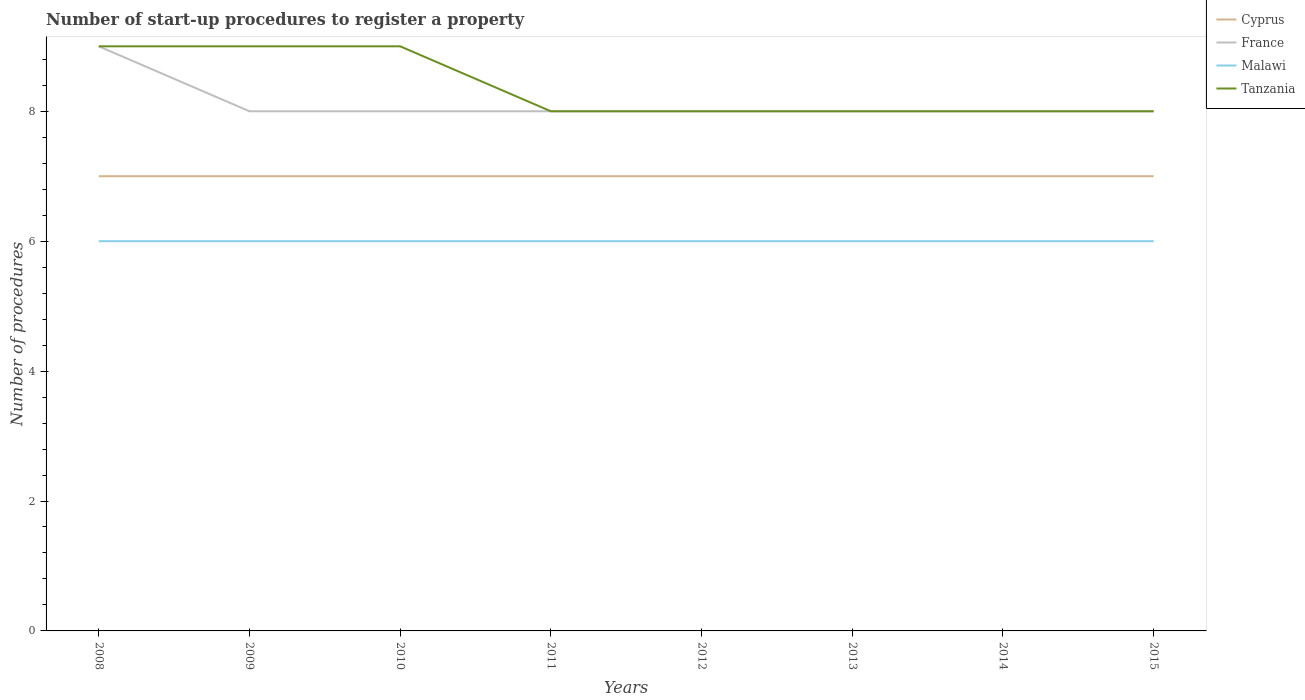Does the line corresponding to Malawi intersect with the line corresponding to Tanzania?
Give a very brief answer. No. Across all years, what is the maximum number of procedures required to register a property in Cyprus?
Keep it short and to the point. 7. In which year was the number of procedures required to register a property in Malawi maximum?
Your answer should be compact. 2008. What is the total number of procedures required to register a property in France in the graph?
Keep it short and to the point. 0. What is the difference between the highest and the second highest number of procedures required to register a property in Malawi?
Your answer should be compact. 0. What is the difference between the highest and the lowest number of procedures required to register a property in France?
Give a very brief answer. 1. Is the number of procedures required to register a property in Tanzania strictly greater than the number of procedures required to register a property in Cyprus over the years?
Provide a short and direct response. No. Where does the legend appear in the graph?
Provide a succinct answer. Top right. How many legend labels are there?
Ensure brevity in your answer.  4. How are the legend labels stacked?
Keep it short and to the point. Vertical. What is the title of the graph?
Make the answer very short. Number of start-up procedures to register a property. What is the label or title of the Y-axis?
Ensure brevity in your answer.  Number of procedures. What is the Number of procedures of France in 2008?
Make the answer very short. 9. What is the Number of procedures in Malawi in 2008?
Provide a succinct answer. 6. What is the Number of procedures in Tanzania in 2008?
Give a very brief answer. 9. What is the Number of procedures in Tanzania in 2009?
Your answer should be very brief. 9. What is the Number of procedures of Cyprus in 2010?
Offer a terse response. 7. What is the Number of procedures of France in 2010?
Make the answer very short. 8. What is the Number of procedures of Malawi in 2010?
Offer a very short reply. 6. What is the Number of procedures in Cyprus in 2011?
Give a very brief answer. 7. What is the Number of procedures in France in 2011?
Keep it short and to the point. 8. What is the Number of procedures in Malawi in 2011?
Offer a terse response. 6. What is the Number of procedures of Tanzania in 2011?
Provide a succinct answer. 8. What is the Number of procedures of Cyprus in 2012?
Offer a terse response. 7. What is the Number of procedures in France in 2012?
Ensure brevity in your answer.  8. What is the Number of procedures of Malawi in 2012?
Provide a succinct answer. 6. What is the Number of procedures in France in 2013?
Your answer should be very brief. 8. What is the Number of procedures of Cyprus in 2014?
Make the answer very short. 7. What is the Number of procedures of Malawi in 2014?
Your answer should be compact. 6. Across all years, what is the maximum Number of procedures in Cyprus?
Your response must be concise. 7. Across all years, what is the maximum Number of procedures in Tanzania?
Make the answer very short. 9. Across all years, what is the minimum Number of procedures of Cyprus?
Offer a very short reply. 7. Across all years, what is the minimum Number of procedures of Tanzania?
Your answer should be very brief. 8. What is the total Number of procedures of France in the graph?
Ensure brevity in your answer.  65. What is the total Number of procedures in Tanzania in the graph?
Your answer should be very brief. 67. What is the difference between the Number of procedures of Cyprus in 2008 and that in 2009?
Offer a terse response. 0. What is the difference between the Number of procedures in France in 2008 and that in 2009?
Your answer should be very brief. 1. What is the difference between the Number of procedures in Tanzania in 2008 and that in 2009?
Your answer should be very brief. 0. What is the difference between the Number of procedures in France in 2008 and that in 2010?
Offer a terse response. 1. What is the difference between the Number of procedures in Tanzania in 2008 and that in 2010?
Offer a very short reply. 0. What is the difference between the Number of procedures in Cyprus in 2008 and that in 2011?
Give a very brief answer. 0. What is the difference between the Number of procedures of France in 2008 and that in 2011?
Provide a short and direct response. 1. What is the difference between the Number of procedures of France in 2008 and that in 2012?
Your answer should be very brief. 1. What is the difference between the Number of procedures in France in 2008 and that in 2013?
Give a very brief answer. 1. What is the difference between the Number of procedures of Malawi in 2008 and that in 2013?
Make the answer very short. 0. What is the difference between the Number of procedures in Tanzania in 2008 and that in 2013?
Keep it short and to the point. 1. What is the difference between the Number of procedures of Tanzania in 2008 and that in 2014?
Keep it short and to the point. 1. What is the difference between the Number of procedures of France in 2009 and that in 2010?
Your answer should be very brief. 0. What is the difference between the Number of procedures of Malawi in 2009 and that in 2010?
Make the answer very short. 0. What is the difference between the Number of procedures of Cyprus in 2009 and that in 2011?
Provide a succinct answer. 0. What is the difference between the Number of procedures of France in 2009 and that in 2011?
Offer a very short reply. 0. What is the difference between the Number of procedures of Malawi in 2009 and that in 2011?
Provide a succinct answer. 0. What is the difference between the Number of procedures in Tanzania in 2009 and that in 2011?
Ensure brevity in your answer.  1. What is the difference between the Number of procedures of Malawi in 2009 and that in 2012?
Provide a short and direct response. 0. What is the difference between the Number of procedures in Tanzania in 2009 and that in 2012?
Provide a short and direct response. 1. What is the difference between the Number of procedures in France in 2009 and that in 2013?
Your answer should be compact. 0. What is the difference between the Number of procedures of Malawi in 2009 and that in 2013?
Give a very brief answer. 0. What is the difference between the Number of procedures in Tanzania in 2009 and that in 2013?
Your response must be concise. 1. What is the difference between the Number of procedures of Cyprus in 2009 and that in 2014?
Your answer should be very brief. 0. What is the difference between the Number of procedures in France in 2009 and that in 2014?
Offer a terse response. 0. What is the difference between the Number of procedures in Cyprus in 2010 and that in 2011?
Make the answer very short. 0. What is the difference between the Number of procedures in France in 2010 and that in 2011?
Your response must be concise. 0. What is the difference between the Number of procedures in Malawi in 2010 and that in 2011?
Your answer should be compact. 0. What is the difference between the Number of procedures of Tanzania in 2010 and that in 2011?
Give a very brief answer. 1. What is the difference between the Number of procedures in Cyprus in 2010 and that in 2012?
Ensure brevity in your answer.  0. What is the difference between the Number of procedures of France in 2010 and that in 2012?
Offer a terse response. 0. What is the difference between the Number of procedures in Tanzania in 2010 and that in 2012?
Your answer should be compact. 1. What is the difference between the Number of procedures of Cyprus in 2010 and that in 2013?
Give a very brief answer. 0. What is the difference between the Number of procedures of France in 2010 and that in 2013?
Ensure brevity in your answer.  0. What is the difference between the Number of procedures in Malawi in 2010 and that in 2013?
Offer a terse response. 0. What is the difference between the Number of procedures in Tanzania in 2010 and that in 2013?
Your answer should be compact. 1. What is the difference between the Number of procedures in Cyprus in 2010 and that in 2014?
Your answer should be very brief. 0. What is the difference between the Number of procedures of France in 2010 and that in 2014?
Offer a very short reply. 0. What is the difference between the Number of procedures in France in 2010 and that in 2015?
Make the answer very short. 0. What is the difference between the Number of procedures in Cyprus in 2011 and that in 2012?
Your answer should be compact. 0. What is the difference between the Number of procedures of Tanzania in 2011 and that in 2012?
Make the answer very short. 0. What is the difference between the Number of procedures of Cyprus in 2011 and that in 2013?
Keep it short and to the point. 0. What is the difference between the Number of procedures of Tanzania in 2011 and that in 2013?
Offer a very short reply. 0. What is the difference between the Number of procedures in Cyprus in 2011 and that in 2014?
Provide a short and direct response. 0. What is the difference between the Number of procedures in Tanzania in 2011 and that in 2014?
Offer a very short reply. 0. What is the difference between the Number of procedures in Cyprus in 2011 and that in 2015?
Offer a very short reply. 0. What is the difference between the Number of procedures of Malawi in 2011 and that in 2015?
Your response must be concise. 0. What is the difference between the Number of procedures in Cyprus in 2012 and that in 2013?
Make the answer very short. 0. What is the difference between the Number of procedures in Malawi in 2012 and that in 2013?
Your answer should be very brief. 0. What is the difference between the Number of procedures of Cyprus in 2012 and that in 2014?
Your response must be concise. 0. What is the difference between the Number of procedures in France in 2012 and that in 2014?
Offer a terse response. 0. What is the difference between the Number of procedures of Cyprus in 2012 and that in 2015?
Ensure brevity in your answer.  0. What is the difference between the Number of procedures of Malawi in 2012 and that in 2015?
Offer a terse response. 0. What is the difference between the Number of procedures in Tanzania in 2012 and that in 2015?
Your answer should be compact. 0. What is the difference between the Number of procedures of Cyprus in 2013 and that in 2014?
Give a very brief answer. 0. What is the difference between the Number of procedures in France in 2013 and that in 2014?
Ensure brevity in your answer.  0. What is the difference between the Number of procedures in Malawi in 2013 and that in 2014?
Your answer should be compact. 0. What is the difference between the Number of procedures in Tanzania in 2013 and that in 2014?
Provide a short and direct response. 0. What is the difference between the Number of procedures of Cyprus in 2013 and that in 2015?
Provide a short and direct response. 0. What is the difference between the Number of procedures of Malawi in 2013 and that in 2015?
Provide a short and direct response. 0. What is the difference between the Number of procedures in France in 2014 and that in 2015?
Your answer should be very brief. 0. What is the difference between the Number of procedures in Cyprus in 2008 and the Number of procedures in France in 2009?
Ensure brevity in your answer.  -1. What is the difference between the Number of procedures of Cyprus in 2008 and the Number of procedures of Tanzania in 2009?
Your answer should be compact. -2. What is the difference between the Number of procedures of Malawi in 2008 and the Number of procedures of Tanzania in 2009?
Give a very brief answer. -3. What is the difference between the Number of procedures in Cyprus in 2008 and the Number of procedures in Malawi in 2010?
Keep it short and to the point. 1. What is the difference between the Number of procedures in France in 2008 and the Number of procedures in Malawi in 2010?
Your answer should be compact. 3. What is the difference between the Number of procedures in Malawi in 2008 and the Number of procedures in Tanzania in 2010?
Provide a short and direct response. -3. What is the difference between the Number of procedures of Cyprus in 2008 and the Number of procedures of Malawi in 2011?
Keep it short and to the point. 1. What is the difference between the Number of procedures in Cyprus in 2008 and the Number of procedures in Tanzania in 2011?
Provide a short and direct response. -1. What is the difference between the Number of procedures of France in 2008 and the Number of procedures of Malawi in 2011?
Provide a short and direct response. 3. What is the difference between the Number of procedures in France in 2008 and the Number of procedures in Tanzania in 2011?
Ensure brevity in your answer.  1. What is the difference between the Number of procedures in Cyprus in 2008 and the Number of procedures in France in 2012?
Provide a succinct answer. -1. What is the difference between the Number of procedures of Cyprus in 2008 and the Number of procedures of Malawi in 2012?
Your answer should be very brief. 1. What is the difference between the Number of procedures in France in 2008 and the Number of procedures in Malawi in 2012?
Give a very brief answer. 3. What is the difference between the Number of procedures in Cyprus in 2008 and the Number of procedures in France in 2013?
Offer a very short reply. -1. What is the difference between the Number of procedures of Cyprus in 2008 and the Number of procedures of Malawi in 2013?
Your response must be concise. 1. What is the difference between the Number of procedures in Cyprus in 2008 and the Number of procedures in Tanzania in 2013?
Offer a terse response. -1. What is the difference between the Number of procedures of France in 2008 and the Number of procedures of Malawi in 2013?
Provide a short and direct response. 3. What is the difference between the Number of procedures of Cyprus in 2008 and the Number of procedures of France in 2014?
Your answer should be very brief. -1. What is the difference between the Number of procedures in Cyprus in 2008 and the Number of procedures in Malawi in 2014?
Offer a terse response. 1. What is the difference between the Number of procedures of Cyprus in 2008 and the Number of procedures of Tanzania in 2014?
Your response must be concise. -1. What is the difference between the Number of procedures of Cyprus in 2008 and the Number of procedures of France in 2015?
Your answer should be very brief. -1. What is the difference between the Number of procedures in France in 2008 and the Number of procedures in Malawi in 2015?
Your response must be concise. 3. What is the difference between the Number of procedures in France in 2008 and the Number of procedures in Tanzania in 2015?
Offer a terse response. 1. What is the difference between the Number of procedures of Cyprus in 2009 and the Number of procedures of France in 2010?
Offer a terse response. -1. What is the difference between the Number of procedures of Malawi in 2009 and the Number of procedures of Tanzania in 2010?
Your answer should be very brief. -3. What is the difference between the Number of procedures in Cyprus in 2009 and the Number of procedures in Tanzania in 2011?
Your answer should be very brief. -1. What is the difference between the Number of procedures in France in 2009 and the Number of procedures in Malawi in 2011?
Provide a succinct answer. 2. What is the difference between the Number of procedures of France in 2009 and the Number of procedures of Tanzania in 2011?
Offer a terse response. 0. What is the difference between the Number of procedures in Cyprus in 2009 and the Number of procedures in France in 2013?
Provide a succinct answer. -1. What is the difference between the Number of procedures in Cyprus in 2009 and the Number of procedures in Tanzania in 2013?
Ensure brevity in your answer.  -1. What is the difference between the Number of procedures of France in 2009 and the Number of procedures of Malawi in 2013?
Offer a very short reply. 2. What is the difference between the Number of procedures in Cyprus in 2009 and the Number of procedures in Tanzania in 2014?
Offer a terse response. -1. What is the difference between the Number of procedures of France in 2009 and the Number of procedures of Malawi in 2014?
Provide a succinct answer. 2. What is the difference between the Number of procedures in Malawi in 2009 and the Number of procedures in Tanzania in 2014?
Offer a terse response. -2. What is the difference between the Number of procedures in Cyprus in 2009 and the Number of procedures in France in 2015?
Your response must be concise. -1. What is the difference between the Number of procedures in Cyprus in 2009 and the Number of procedures in Tanzania in 2015?
Provide a short and direct response. -1. What is the difference between the Number of procedures in France in 2009 and the Number of procedures in Tanzania in 2015?
Provide a succinct answer. 0. What is the difference between the Number of procedures of Cyprus in 2010 and the Number of procedures of Tanzania in 2011?
Your answer should be very brief. -1. What is the difference between the Number of procedures of France in 2010 and the Number of procedures of Malawi in 2011?
Provide a succinct answer. 2. What is the difference between the Number of procedures in France in 2010 and the Number of procedures in Tanzania in 2011?
Provide a short and direct response. 0. What is the difference between the Number of procedures in France in 2010 and the Number of procedures in Malawi in 2012?
Make the answer very short. 2. What is the difference between the Number of procedures in France in 2010 and the Number of procedures in Tanzania in 2012?
Your response must be concise. 0. What is the difference between the Number of procedures in Cyprus in 2010 and the Number of procedures in France in 2013?
Your answer should be very brief. -1. What is the difference between the Number of procedures of France in 2010 and the Number of procedures of Malawi in 2013?
Keep it short and to the point. 2. What is the difference between the Number of procedures in Malawi in 2010 and the Number of procedures in Tanzania in 2013?
Ensure brevity in your answer.  -2. What is the difference between the Number of procedures in Cyprus in 2010 and the Number of procedures in France in 2014?
Make the answer very short. -1. What is the difference between the Number of procedures of Cyprus in 2010 and the Number of procedures of Tanzania in 2014?
Keep it short and to the point. -1. What is the difference between the Number of procedures in Malawi in 2010 and the Number of procedures in Tanzania in 2014?
Your answer should be compact. -2. What is the difference between the Number of procedures in Cyprus in 2010 and the Number of procedures in France in 2015?
Offer a very short reply. -1. What is the difference between the Number of procedures in Cyprus in 2010 and the Number of procedures in Malawi in 2015?
Offer a very short reply. 1. What is the difference between the Number of procedures in France in 2010 and the Number of procedures in Malawi in 2015?
Offer a very short reply. 2. What is the difference between the Number of procedures in France in 2010 and the Number of procedures in Tanzania in 2015?
Make the answer very short. 0. What is the difference between the Number of procedures of Malawi in 2010 and the Number of procedures of Tanzania in 2015?
Provide a short and direct response. -2. What is the difference between the Number of procedures in Cyprus in 2011 and the Number of procedures in France in 2012?
Keep it short and to the point. -1. What is the difference between the Number of procedures in Cyprus in 2011 and the Number of procedures in Tanzania in 2012?
Keep it short and to the point. -1. What is the difference between the Number of procedures of Malawi in 2011 and the Number of procedures of Tanzania in 2012?
Your response must be concise. -2. What is the difference between the Number of procedures of France in 2011 and the Number of procedures of Malawi in 2013?
Provide a succinct answer. 2. What is the difference between the Number of procedures in France in 2011 and the Number of procedures in Tanzania in 2013?
Your answer should be very brief. 0. What is the difference between the Number of procedures in Cyprus in 2011 and the Number of procedures in France in 2014?
Ensure brevity in your answer.  -1. What is the difference between the Number of procedures in Cyprus in 2011 and the Number of procedures in Malawi in 2014?
Keep it short and to the point. 1. What is the difference between the Number of procedures of France in 2011 and the Number of procedures of Tanzania in 2014?
Your answer should be compact. 0. What is the difference between the Number of procedures in Cyprus in 2011 and the Number of procedures in France in 2015?
Your answer should be very brief. -1. What is the difference between the Number of procedures of France in 2011 and the Number of procedures of Tanzania in 2015?
Provide a succinct answer. 0. What is the difference between the Number of procedures of Malawi in 2011 and the Number of procedures of Tanzania in 2015?
Your response must be concise. -2. What is the difference between the Number of procedures of Cyprus in 2012 and the Number of procedures of France in 2013?
Ensure brevity in your answer.  -1. What is the difference between the Number of procedures in Cyprus in 2012 and the Number of procedures in Tanzania in 2013?
Your response must be concise. -1. What is the difference between the Number of procedures of France in 2012 and the Number of procedures of Malawi in 2013?
Provide a succinct answer. 2. What is the difference between the Number of procedures in France in 2012 and the Number of procedures in Tanzania in 2013?
Your response must be concise. 0. What is the difference between the Number of procedures in Cyprus in 2012 and the Number of procedures in France in 2014?
Keep it short and to the point. -1. What is the difference between the Number of procedures in Cyprus in 2012 and the Number of procedures in Malawi in 2014?
Make the answer very short. 1. What is the difference between the Number of procedures in Cyprus in 2012 and the Number of procedures in Tanzania in 2014?
Your response must be concise. -1. What is the difference between the Number of procedures of France in 2012 and the Number of procedures of Tanzania in 2015?
Offer a very short reply. 0. What is the difference between the Number of procedures in Cyprus in 2013 and the Number of procedures in France in 2014?
Offer a terse response. -1. What is the difference between the Number of procedures in Cyprus in 2013 and the Number of procedures in Tanzania in 2014?
Ensure brevity in your answer.  -1. What is the difference between the Number of procedures of France in 2013 and the Number of procedures of Malawi in 2014?
Make the answer very short. 2. What is the difference between the Number of procedures in France in 2013 and the Number of procedures in Tanzania in 2014?
Your response must be concise. 0. What is the difference between the Number of procedures in Cyprus in 2013 and the Number of procedures in Malawi in 2015?
Offer a very short reply. 1. What is the difference between the Number of procedures of Cyprus in 2013 and the Number of procedures of Tanzania in 2015?
Offer a very short reply. -1. What is the difference between the Number of procedures of France in 2013 and the Number of procedures of Malawi in 2015?
Your answer should be compact. 2. What is the difference between the Number of procedures in Malawi in 2013 and the Number of procedures in Tanzania in 2015?
Offer a very short reply. -2. What is the difference between the Number of procedures of Cyprus in 2014 and the Number of procedures of France in 2015?
Your answer should be very brief. -1. What is the difference between the Number of procedures in France in 2014 and the Number of procedures in Malawi in 2015?
Offer a very short reply. 2. What is the difference between the Number of procedures in France in 2014 and the Number of procedures in Tanzania in 2015?
Your answer should be compact. 0. What is the average Number of procedures in France per year?
Provide a short and direct response. 8.12. What is the average Number of procedures of Tanzania per year?
Provide a succinct answer. 8.38. In the year 2008, what is the difference between the Number of procedures of Cyprus and Number of procedures of Malawi?
Offer a very short reply. 1. In the year 2008, what is the difference between the Number of procedures in Cyprus and Number of procedures in Tanzania?
Make the answer very short. -2. In the year 2008, what is the difference between the Number of procedures of France and Number of procedures of Malawi?
Offer a very short reply. 3. In the year 2009, what is the difference between the Number of procedures in Cyprus and Number of procedures in Malawi?
Provide a succinct answer. 1. In the year 2009, what is the difference between the Number of procedures in Cyprus and Number of procedures in Tanzania?
Your response must be concise. -2. In the year 2009, what is the difference between the Number of procedures of France and Number of procedures of Malawi?
Your answer should be compact. 2. In the year 2009, what is the difference between the Number of procedures in France and Number of procedures in Tanzania?
Give a very brief answer. -1. In the year 2010, what is the difference between the Number of procedures in Cyprus and Number of procedures in France?
Offer a terse response. -1. In the year 2010, what is the difference between the Number of procedures of Cyprus and Number of procedures of Malawi?
Provide a short and direct response. 1. In the year 2010, what is the difference between the Number of procedures of Cyprus and Number of procedures of Tanzania?
Offer a very short reply. -2. In the year 2010, what is the difference between the Number of procedures in France and Number of procedures in Malawi?
Give a very brief answer. 2. In the year 2010, what is the difference between the Number of procedures of Malawi and Number of procedures of Tanzania?
Offer a terse response. -3. In the year 2011, what is the difference between the Number of procedures in Cyprus and Number of procedures in France?
Provide a short and direct response. -1. In the year 2011, what is the difference between the Number of procedures of Cyprus and Number of procedures of Tanzania?
Offer a very short reply. -1. In the year 2011, what is the difference between the Number of procedures in France and Number of procedures in Tanzania?
Your answer should be very brief. 0. In the year 2012, what is the difference between the Number of procedures in Cyprus and Number of procedures in Malawi?
Your response must be concise. 1. In the year 2012, what is the difference between the Number of procedures of Cyprus and Number of procedures of Tanzania?
Keep it short and to the point. -1. In the year 2013, what is the difference between the Number of procedures in Cyprus and Number of procedures in France?
Your answer should be very brief. -1. In the year 2013, what is the difference between the Number of procedures in Cyprus and Number of procedures in Malawi?
Offer a terse response. 1. In the year 2013, what is the difference between the Number of procedures in Cyprus and Number of procedures in Tanzania?
Your response must be concise. -1. In the year 2013, what is the difference between the Number of procedures of France and Number of procedures of Tanzania?
Give a very brief answer. 0. In the year 2013, what is the difference between the Number of procedures of Malawi and Number of procedures of Tanzania?
Make the answer very short. -2. In the year 2014, what is the difference between the Number of procedures in Cyprus and Number of procedures in France?
Ensure brevity in your answer.  -1. In the year 2014, what is the difference between the Number of procedures of France and Number of procedures of Malawi?
Your response must be concise. 2. In the year 2015, what is the difference between the Number of procedures in Cyprus and Number of procedures in France?
Your answer should be very brief. -1. In the year 2015, what is the difference between the Number of procedures of France and Number of procedures of Malawi?
Your answer should be compact. 2. In the year 2015, what is the difference between the Number of procedures in Malawi and Number of procedures in Tanzania?
Provide a succinct answer. -2. What is the ratio of the Number of procedures in Cyprus in 2008 to that in 2009?
Make the answer very short. 1. What is the ratio of the Number of procedures of France in 2008 to that in 2009?
Keep it short and to the point. 1.12. What is the ratio of the Number of procedures in Tanzania in 2008 to that in 2009?
Make the answer very short. 1. What is the ratio of the Number of procedures in Tanzania in 2008 to that in 2010?
Keep it short and to the point. 1. What is the ratio of the Number of procedures of France in 2008 to that in 2011?
Your answer should be very brief. 1.12. What is the ratio of the Number of procedures in Tanzania in 2008 to that in 2011?
Keep it short and to the point. 1.12. What is the ratio of the Number of procedures of France in 2008 to that in 2013?
Make the answer very short. 1.12. What is the ratio of the Number of procedures in Tanzania in 2008 to that in 2013?
Offer a terse response. 1.12. What is the ratio of the Number of procedures in France in 2008 to that in 2015?
Your response must be concise. 1.12. What is the ratio of the Number of procedures in Malawi in 2008 to that in 2015?
Give a very brief answer. 1. What is the ratio of the Number of procedures of Malawi in 2009 to that in 2010?
Your response must be concise. 1. What is the ratio of the Number of procedures of Tanzania in 2009 to that in 2010?
Make the answer very short. 1. What is the ratio of the Number of procedures in Cyprus in 2009 to that in 2011?
Keep it short and to the point. 1. What is the ratio of the Number of procedures in France in 2009 to that in 2011?
Make the answer very short. 1. What is the ratio of the Number of procedures of Malawi in 2009 to that in 2012?
Give a very brief answer. 1. What is the ratio of the Number of procedures of Tanzania in 2009 to that in 2012?
Offer a very short reply. 1.12. What is the ratio of the Number of procedures of Cyprus in 2009 to that in 2014?
Give a very brief answer. 1. What is the ratio of the Number of procedures of Malawi in 2009 to that in 2014?
Provide a succinct answer. 1. What is the ratio of the Number of procedures of Tanzania in 2009 to that in 2014?
Make the answer very short. 1.12. What is the ratio of the Number of procedures of Cyprus in 2009 to that in 2015?
Keep it short and to the point. 1. What is the ratio of the Number of procedures of France in 2009 to that in 2015?
Offer a terse response. 1. What is the ratio of the Number of procedures of Malawi in 2009 to that in 2015?
Give a very brief answer. 1. What is the ratio of the Number of procedures in Tanzania in 2009 to that in 2015?
Your answer should be very brief. 1.12. What is the ratio of the Number of procedures in Cyprus in 2010 to that in 2011?
Your response must be concise. 1. What is the ratio of the Number of procedures of France in 2010 to that in 2011?
Offer a terse response. 1. What is the ratio of the Number of procedures in France in 2010 to that in 2012?
Your response must be concise. 1. What is the ratio of the Number of procedures in Cyprus in 2010 to that in 2013?
Give a very brief answer. 1. What is the ratio of the Number of procedures in Malawi in 2010 to that in 2014?
Provide a short and direct response. 1. What is the ratio of the Number of procedures in Tanzania in 2010 to that in 2014?
Provide a short and direct response. 1.12. What is the ratio of the Number of procedures of Cyprus in 2010 to that in 2015?
Provide a succinct answer. 1. What is the ratio of the Number of procedures of France in 2010 to that in 2015?
Your response must be concise. 1. What is the ratio of the Number of procedures in Cyprus in 2011 to that in 2012?
Your answer should be very brief. 1. What is the ratio of the Number of procedures of France in 2011 to that in 2012?
Your answer should be very brief. 1. What is the ratio of the Number of procedures in Tanzania in 2011 to that in 2012?
Provide a short and direct response. 1. What is the ratio of the Number of procedures in France in 2011 to that in 2013?
Offer a terse response. 1. What is the ratio of the Number of procedures of Tanzania in 2011 to that in 2013?
Your response must be concise. 1. What is the ratio of the Number of procedures in France in 2011 to that in 2014?
Offer a very short reply. 1. What is the ratio of the Number of procedures in Cyprus in 2011 to that in 2015?
Ensure brevity in your answer.  1. What is the ratio of the Number of procedures of France in 2011 to that in 2015?
Give a very brief answer. 1. What is the ratio of the Number of procedures of Malawi in 2012 to that in 2013?
Ensure brevity in your answer.  1. What is the ratio of the Number of procedures of Tanzania in 2012 to that in 2013?
Give a very brief answer. 1. What is the ratio of the Number of procedures in France in 2012 to that in 2014?
Your response must be concise. 1. What is the ratio of the Number of procedures of Cyprus in 2012 to that in 2015?
Keep it short and to the point. 1. What is the ratio of the Number of procedures in Malawi in 2012 to that in 2015?
Provide a short and direct response. 1. What is the ratio of the Number of procedures in Tanzania in 2012 to that in 2015?
Provide a succinct answer. 1. What is the ratio of the Number of procedures in Cyprus in 2013 to that in 2014?
Your response must be concise. 1. What is the ratio of the Number of procedures of Malawi in 2013 to that in 2015?
Your response must be concise. 1. What is the ratio of the Number of procedures of Cyprus in 2014 to that in 2015?
Give a very brief answer. 1. What is the ratio of the Number of procedures of Malawi in 2014 to that in 2015?
Make the answer very short. 1. What is the difference between the highest and the second highest Number of procedures of Cyprus?
Keep it short and to the point. 0. What is the difference between the highest and the second highest Number of procedures in France?
Ensure brevity in your answer.  1. What is the difference between the highest and the second highest Number of procedures in Tanzania?
Make the answer very short. 0. What is the difference between the highest and the lowest Number of procedures in France?
Your answer should be very brief. 1. What is the difference between the highest and the lowest Number of procedures of Malawi?
Your answer should be very brief. 0. 